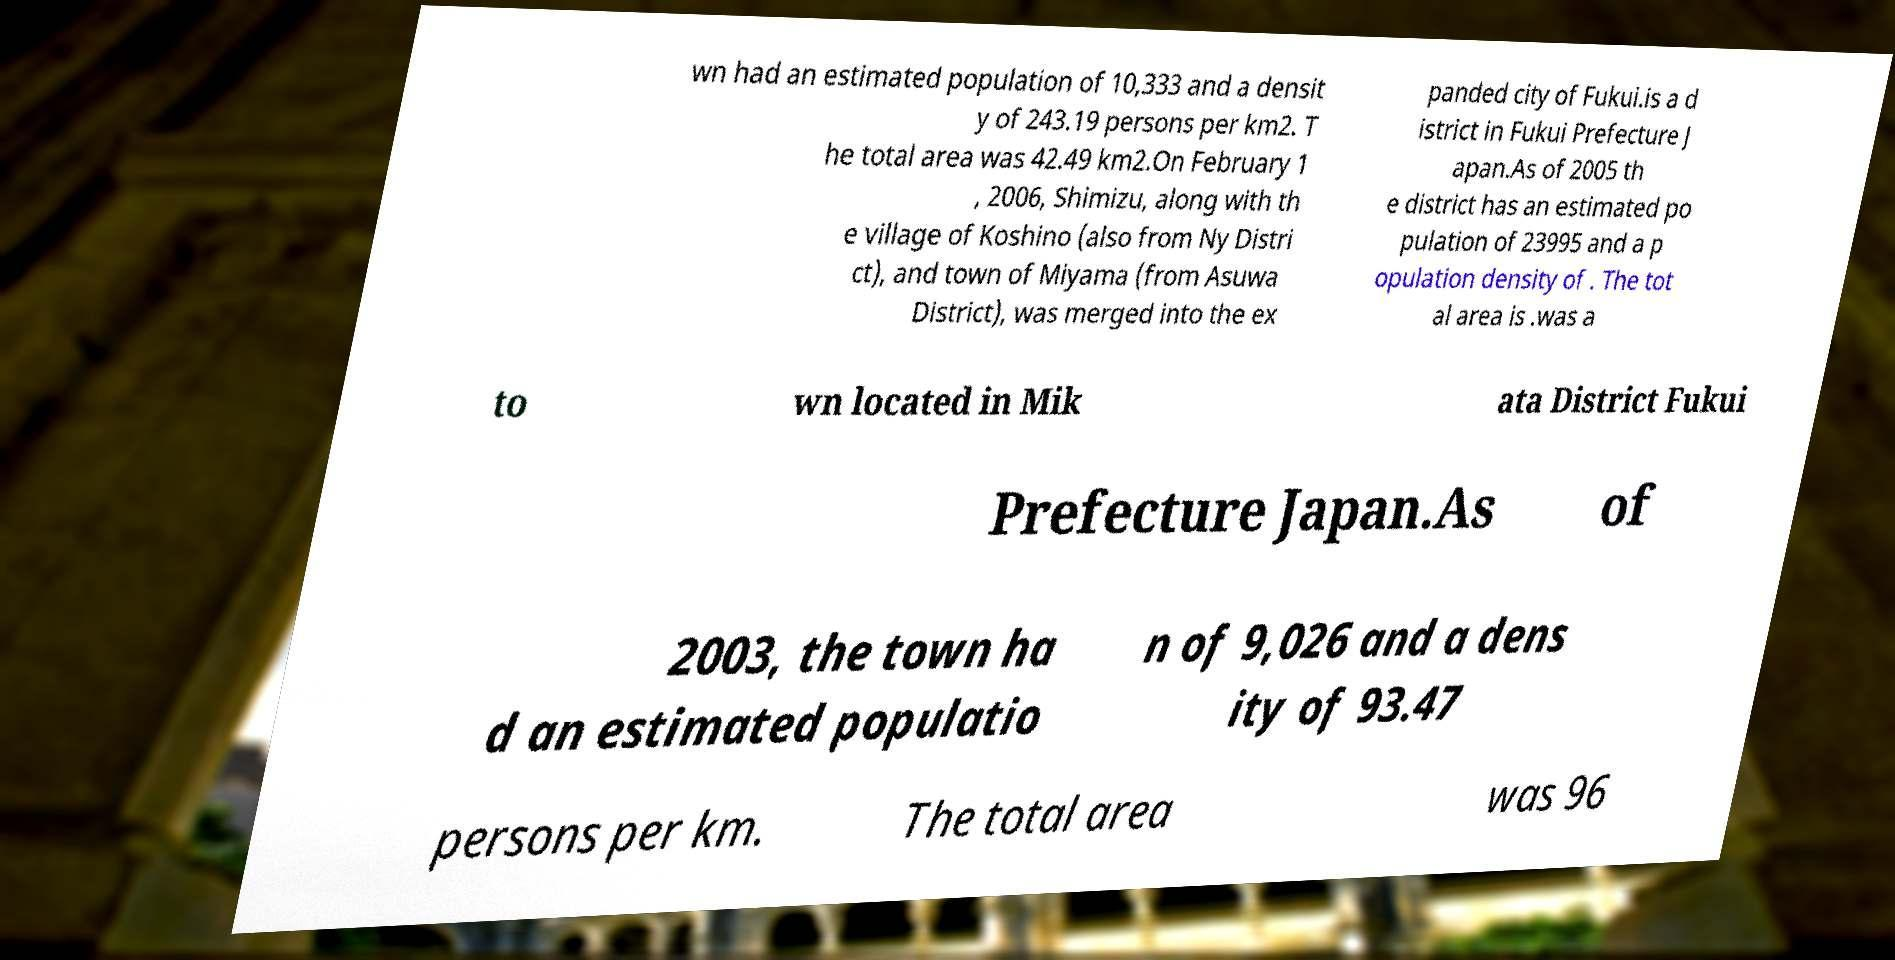Please identify and transcribe the text found in this image. wn had an estimated population of 10,333 and a densit y of 243.19 persons per km2. T he total area was 42.49 km2.On February 1 , 2006, Shimizu, along with th e village of Koshino (also from Ny Distri ct), and town of Miyama (from Asuwa District), was merged into the ex panded city of Fukui.is a d istrict in Fukui Prefecture J apan.As of 2005 th e district has an estimated po pulation of 23995 and a p opulation density of . The tot al area is .was a to wn located in Mik ata District Fukui Prefecture Japan.As of 2003, the town ha d an estimated populatio n of 9,026 and a dens ity of 93.47 persons per km. The total area was 96 